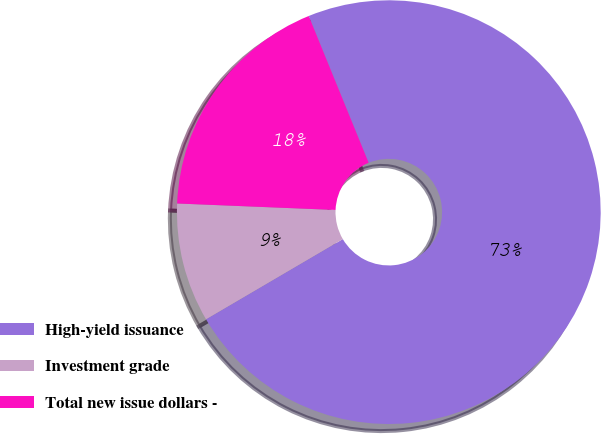Convert chart to OTSL. <chart><loc_0><loc_0><loc_500><loc_500><pie_chart><fcel>High-yield issuance<fcel>Investment grade<fcel>Total new issue dollars -<nl><fcel>72.73%<fcel>9.09%<fcel>18.18%<nl></chart> 